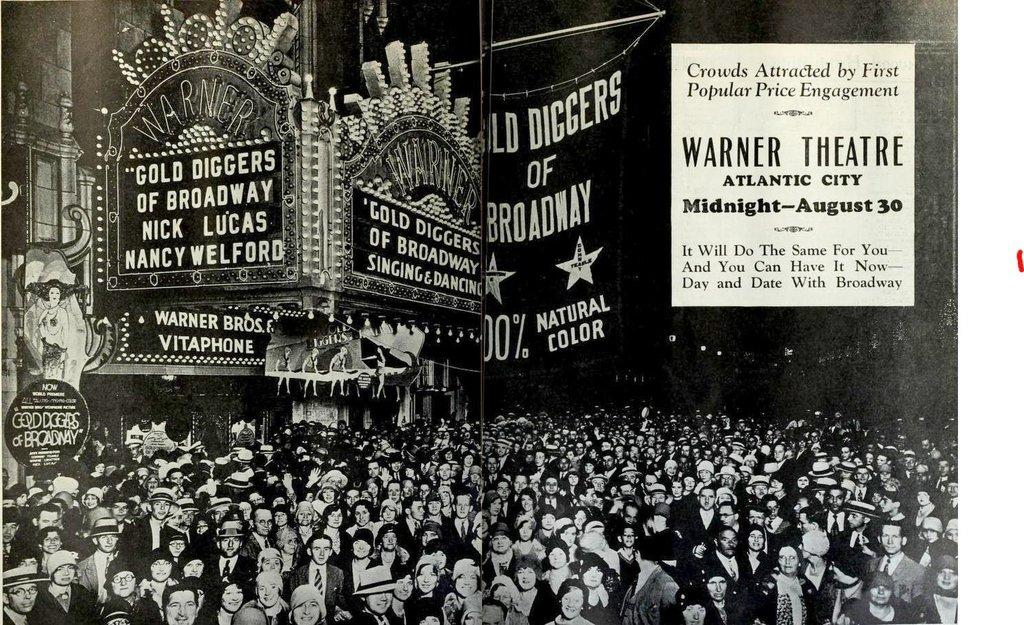<image>
Give a short and clear explanation of the subsequent image. An old picture showing the Warner Theatre in Atlantic City. 